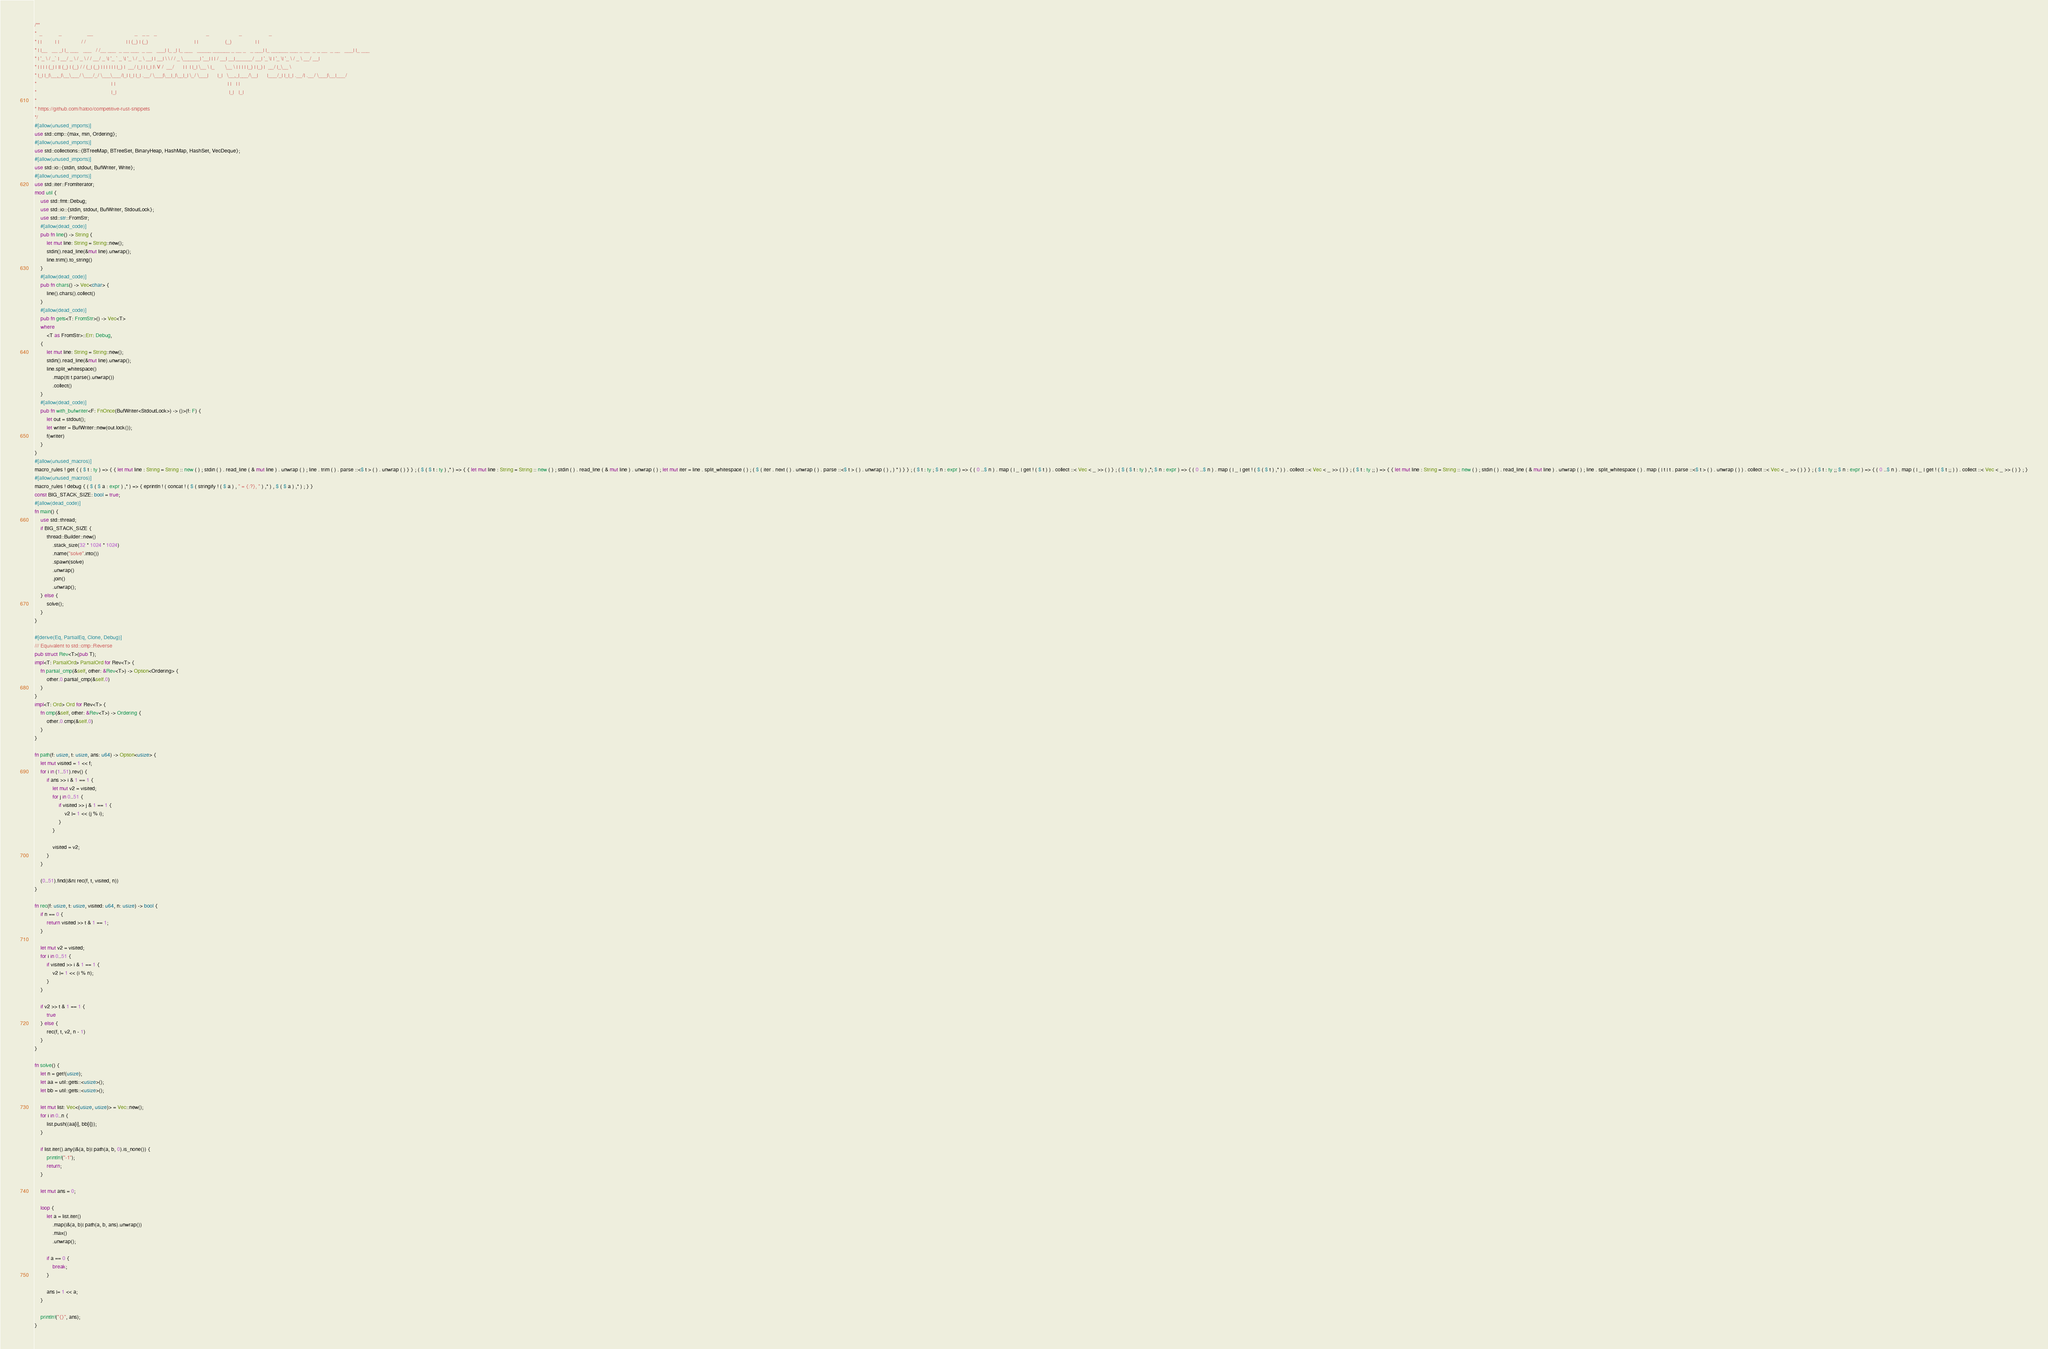Convert code to text. <code><loc_0><loc_0><loc_500><loc_500><_Rust_>/**
*  _           _                 __                            _   _ _   _                                 _                    _                  _
* | |         | |               / /                           | | (_) | (_)                               | |                  (_)                | |
* | |__   __ _| |_ ___   ___   / /__ ___  _ __ ___  _ __   ___| |_ _| |_ ___   _____ ______ _ __ _   _ ___| |_ ______ ___ _ __  _ _ __  _ __   ___| |_ ___
* | '_ \ / _` | __/ _ \ / _ \ / / __/ _ \| '_ ` _ \| '_ \ / _ \ __| | __| \ \ / / _ \______| '__| | | / __| __|______/ __| '_ \| | '_ \| '_ \ / _ \ __/ __|
* | | | | (_| | || (_) | (_) / / (_| (_) | | | | | | |_) |  __/ |_| | |_| |\ V /  __/      | |  | |_| \__ \ |_       \__ \ | | | | |_) | |_) |  __/ |_\__ \
* |_| |_|\__,_|\__\___/ \___/_/ \___\___/|_| |_| |_| .__/ \___|\__|_|\__|_| \_/ \___|      |_|   \__,_|___/\__|      |___/_| |_|_| .__/| .__/ \___|\__|___/
*                                                  | |                                                                           | |   | |
*                                                  |_|                                                                           |_|   |_|
*
* https://github.com/hatoo/competitive-rust-snippets
*/
#[allow(unused_imports)]
use std::cmp::{max, min, Ordering};
#[allow(unused_imports)]
use std::collections::{BTreeMap, BTreeSet, BinaryHeap, HashMap, HashSet, VecDeque};
#[allow(unused_imports)]
use std::io::{stdin, stdout, BufWriter, Write};
#[allow(unused_imports)]
use std::iter::FromIterator;
mod util {
    use std::fmt::Debug;
    use std::io::{stdin, stdout, BufWriter, StdoutLock};
    use std::str::FromStr;
    #[allow(dead_code)]
    pub fn line() -> String {
        let mut line: String = String::new();
        stdin().read_line(&mut line).unwrap();
        line.trim().to_string()
    }
    #[allow(dead_code)]
    pub fn chars() -> Vec<char> {
        line().chars().collect()
    }
    #[allow(dead_code)]
    pub fn gets<T: FromStr>() -> Vec<T>
    where
        <T as FromStr>::Err: Debug,
    {
        let mut line: String = String::new();
        stdin().read_line(&mut line).unwrap();
        line.split_whitespace()
            .map(|t| t.parse().unwrap())
            .collect()
    }
    #[allow(dead_code)]
    pub fn with_bufwriter<F: FnOnce(BufWriter<StdoutLock>) -> ()>(f: F) {
        let out = stdout();
        let writer = BufWriter::new(out.lock());
        f(writer)
    }
}
#[allow(unused_macros)]
macro_rules ! get { ( $ t : ty ) => { { let mut line : String = String :: new ( ) ; stdin ( ) . read_line ( & mut line ) . unwrap ( ) ; line . trim ( ) . parse ::<$ t > ( ) . unwrap ( ) } } ; ( $ ( $ t : ty ) ,* ) => { { let mut line : String = String :: new ( ) ; stdin ( ) . read_line ( & mut line ) . unwrap ( ) ; let mut iter = line . split_whitespace ( ) ; ( $ ( iter . next ( ) . unwrap ( ) . parse ::<$ t > ( ) . unwrap ( ) , ) * ) } } ; ( $ t : ty ; $ n : expr ) => { ( 0 ..$ n ) . map ( | _ | get ! ( $ t ) ) . collect ::< Vec < _ >> ( ) } ; ( $ ( $ t : ty ) ,*; $ n : expr ) => { ( 0 ..$ n ) . map ( | _ | get ! ( $ ( $ t ) ,* ) ) . collect ::< Vec < _ >> ( ) } ; ( $ t : ty ;; ) => { { let mut line : String = String :: new ( ) ; stdin ( ) . read_line ( & mut line ) . unwrap ( ) ; line . split_whitespace ( ) . map ( | t | t . parse ::<$ t > ( ) . unwrap ( ) ) . collect ::< Vec < _ >> ( ) } } ; ( $ t : ty ;; $ n : expr ) => { ( 0 ..$ n ) . map ( | _ | get ! ( $ t ;; ) ) . collect ::< Vec < _ >> ( ) } ; }
#[allow(unused_macros)]
macro_rules ! debug { ( $ ( $ a : expr ) ,* ) => { eprintln ! ( concat ! ( $ ( stringify ! ( $ a ) , " = {:?}, " ) ,* ) , $ ( $ a ) ,* ) ; } }
const BIG_STACK_SIZE: bool = true;
#[allow(dead_code)]
fn main() {
    use std::thread;
    if BIG_STACK_SIZE {
        thread::Builder::new()
            .stack_size(32 * 1024 * 1024)
            .name("solve".into())
            .spawn(solve)
            .unwrap()
            .join()
            .unwrap();
    } else {
        solve();
    }
}

#[derive(Eq, PartialEq, Clone, Debug)]
/// Equivalent to std::cmp::Reverse
pub struct Rev<T>(pub T);
impl<T: PartialOrd> PartialOrd for Rev<T> {
    fn partial_cmp(&self, other: &Rev<T>) -> Option<Ordering> {
        other.0.partial_cmp(&self.0)
    }
}
impl<T: Ord> Ord for Rev<T> {
    fn cmp(&self, other: &Rev<T>) -> Ordering {
        other.0.cmp(&self.0)
    }
}

fn path(f: usize, t: usize, ans: u64) -> Option<usize> {
    let mut visited = 1 << f;
    for i in (1..51).rev() {
        if ans >> i & 1 == 1 {
            let mut v2 = visited;
            for j in 0..51 {
                if visited >> j & 1 == 1 {
                    v2 |= 1 << (j % i);
                }
            }

            visited = v2;
        }
    }

    (0..51).find(|&n| rec(f, t, visited, n))
}

fn rec(f: usize, t: usize, visited: u64, n: usize) -> bool {
    if n == 0 {
        return visited >> t & 1 == 1;
    }

    let mut v2 = visited;
    for i in 0..51 {
        if visited >> i & 1 == 1 {
            v2 |= 1 << (i % n);
        }
    }

    if v2 >> t & 1 == 1 {
        true
    } else {
        rec(f, t, v2, n - 1)
    }
}

fn solve() {
    let n = get!(usize);
    let aa = util::gets::<usize>();
    let bb = util::gets::<usize>();

    let mut list: Vec<(usize, usize)> = Vec::new();
    for i in 0..n {
        list.push((aa[i], bb[i]));
    }

    if list.iter().any(|&(a, b)| path(a, b, 0).is_none()) {
        println!("-1");
        return;
    }

    let mut ans = 0;

    loop {
        let a = list.iter()
            .map(|&(a, b)| path(a, b, ans).unwrap())
            .max()
            .unwrap();

        if a == 0 {
            break;
        }

        ans |= 1 << a;
    }

    println!("{}", ans);
}
</code> 